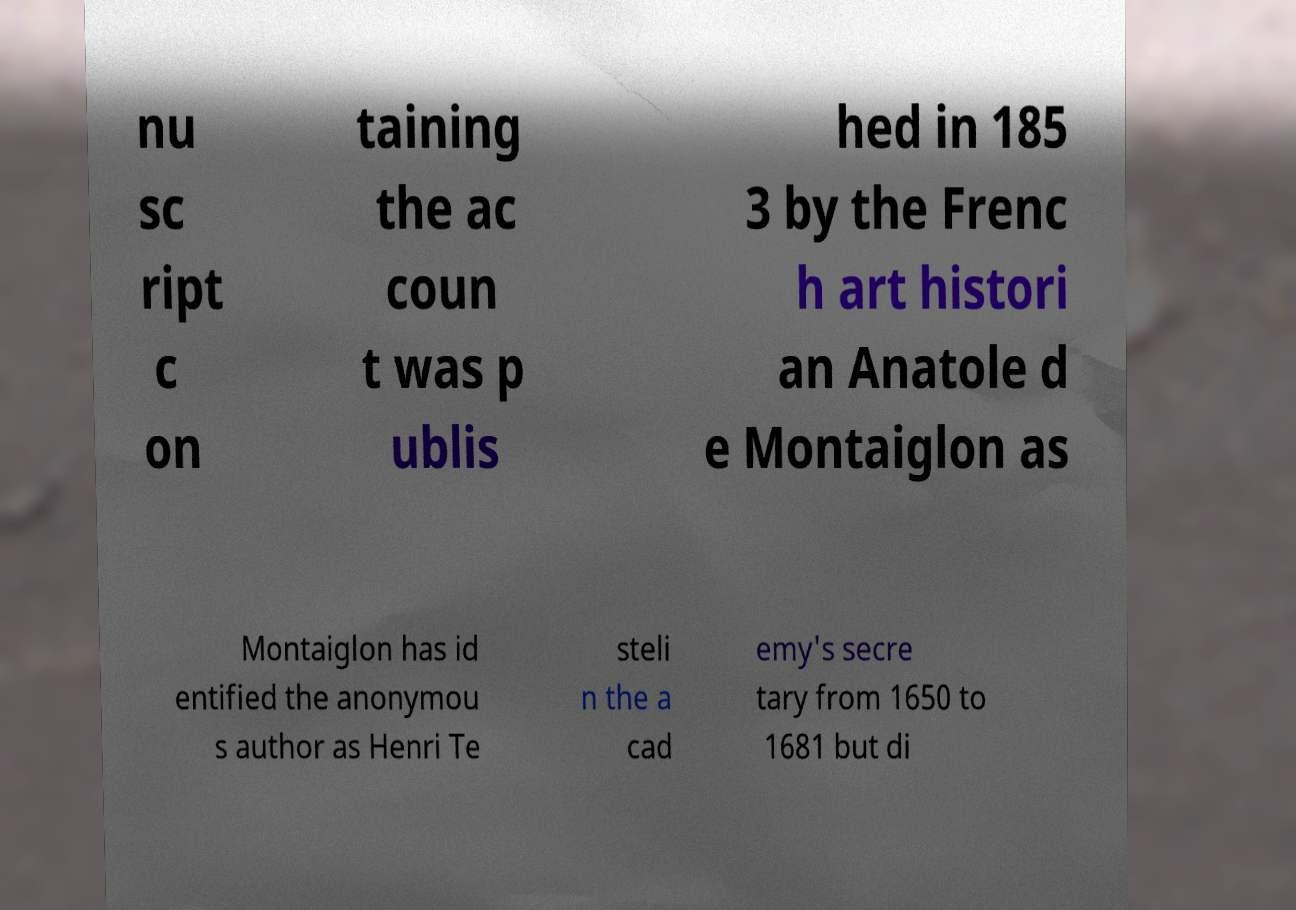Please read and relay the text visible in this image. What does it say? nu sc ript c on taining the ac coun t was p ublis hed in 185 3 by the Frenc h art histori an Anatole d e Montaiglon as Montaiglon has id entified the anonymou s author as Henri Te steli n the a cad emy's secre tary from 1650 to 1681 but di 